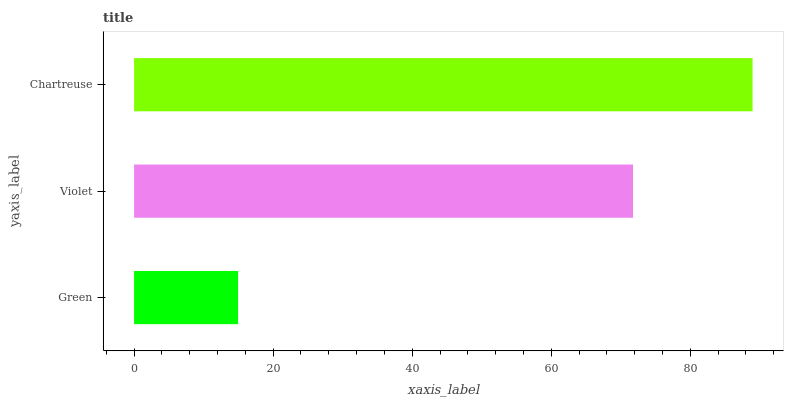Is Green the minimum?
Answer yes or no. Yes. Is Chartreuse the maximum?
Answer yes or no. Yes. Is Violet the minimum?
Answer yes or no. No. Is Violet the maximum?
Answer yes or no. No. Is Violet greater than Green?
Answer yes or no. Yes. Is Green less than Violet?
Answer yes or no. Yes. Is Green greater than Violet?
Answer yes or no. No. Is Violet less than Green?
Answer yes or no. No. Is Violet the high median?
Answer yes or no. Yes. Is Violet the low median?
Answer yes or no. Yes. Is Green the high median?
Answer yes or no. No. Is Green the low median?
Answer yes or no. No. 